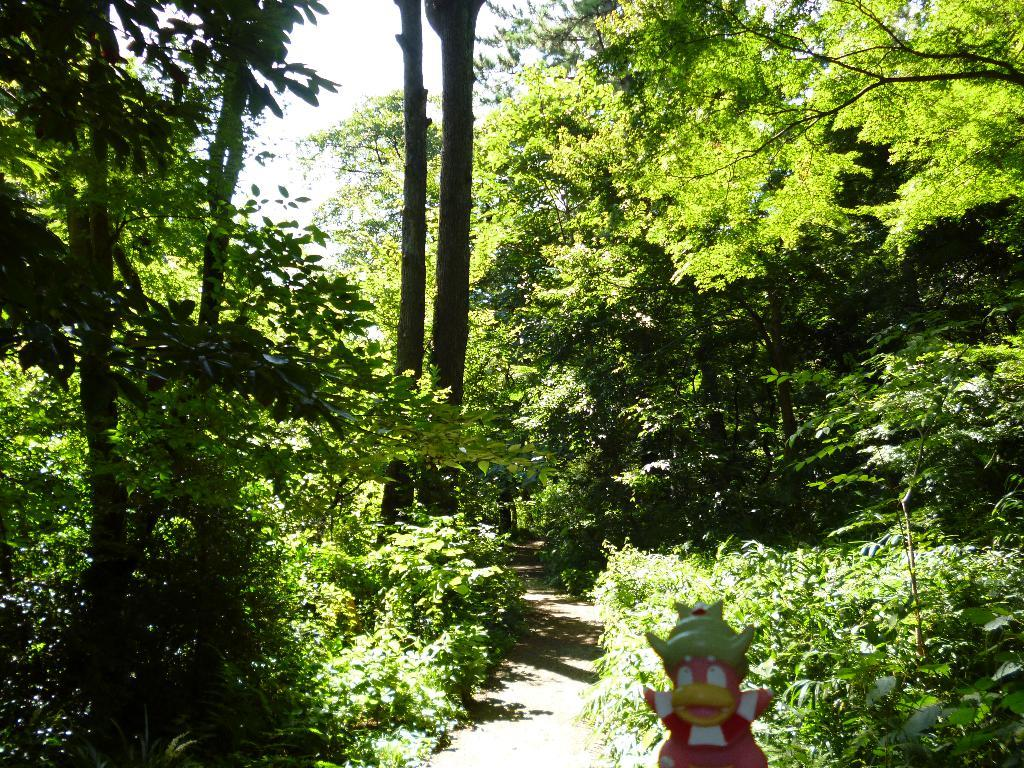What object can be seen in the image that is meant for play or entertainment? There is a toy in the image. What type of path is visible in the image? There is a walkway in the image. What type of vegetation is present in the image? There are trees in the image. What type of art can be seen on the toy in the image? There is no art present on the toy in the image; it is a simple play object. 